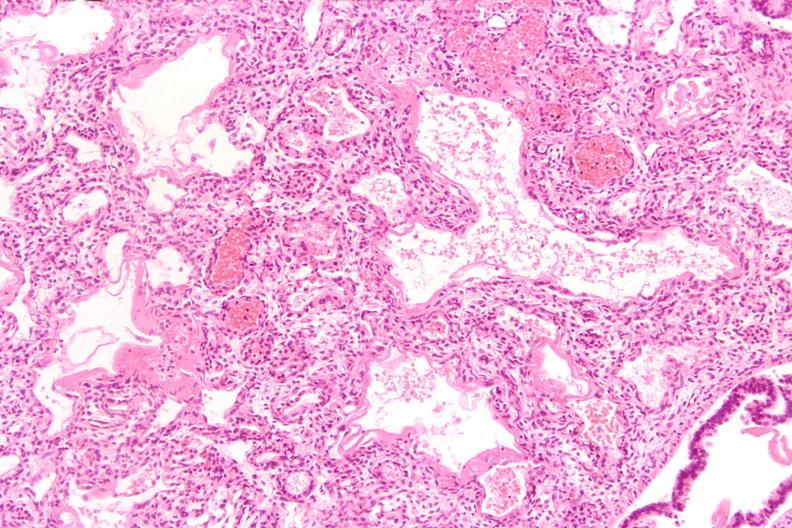s sacrococcygeal teratoma present?
Answer the question using a single word or phrase. No 